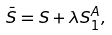<formula> <loc_0><loc_0><loc_500><loc_500>\bar { S } = S + \lambda S _ { 1 } ^ { A } ,</formula> 